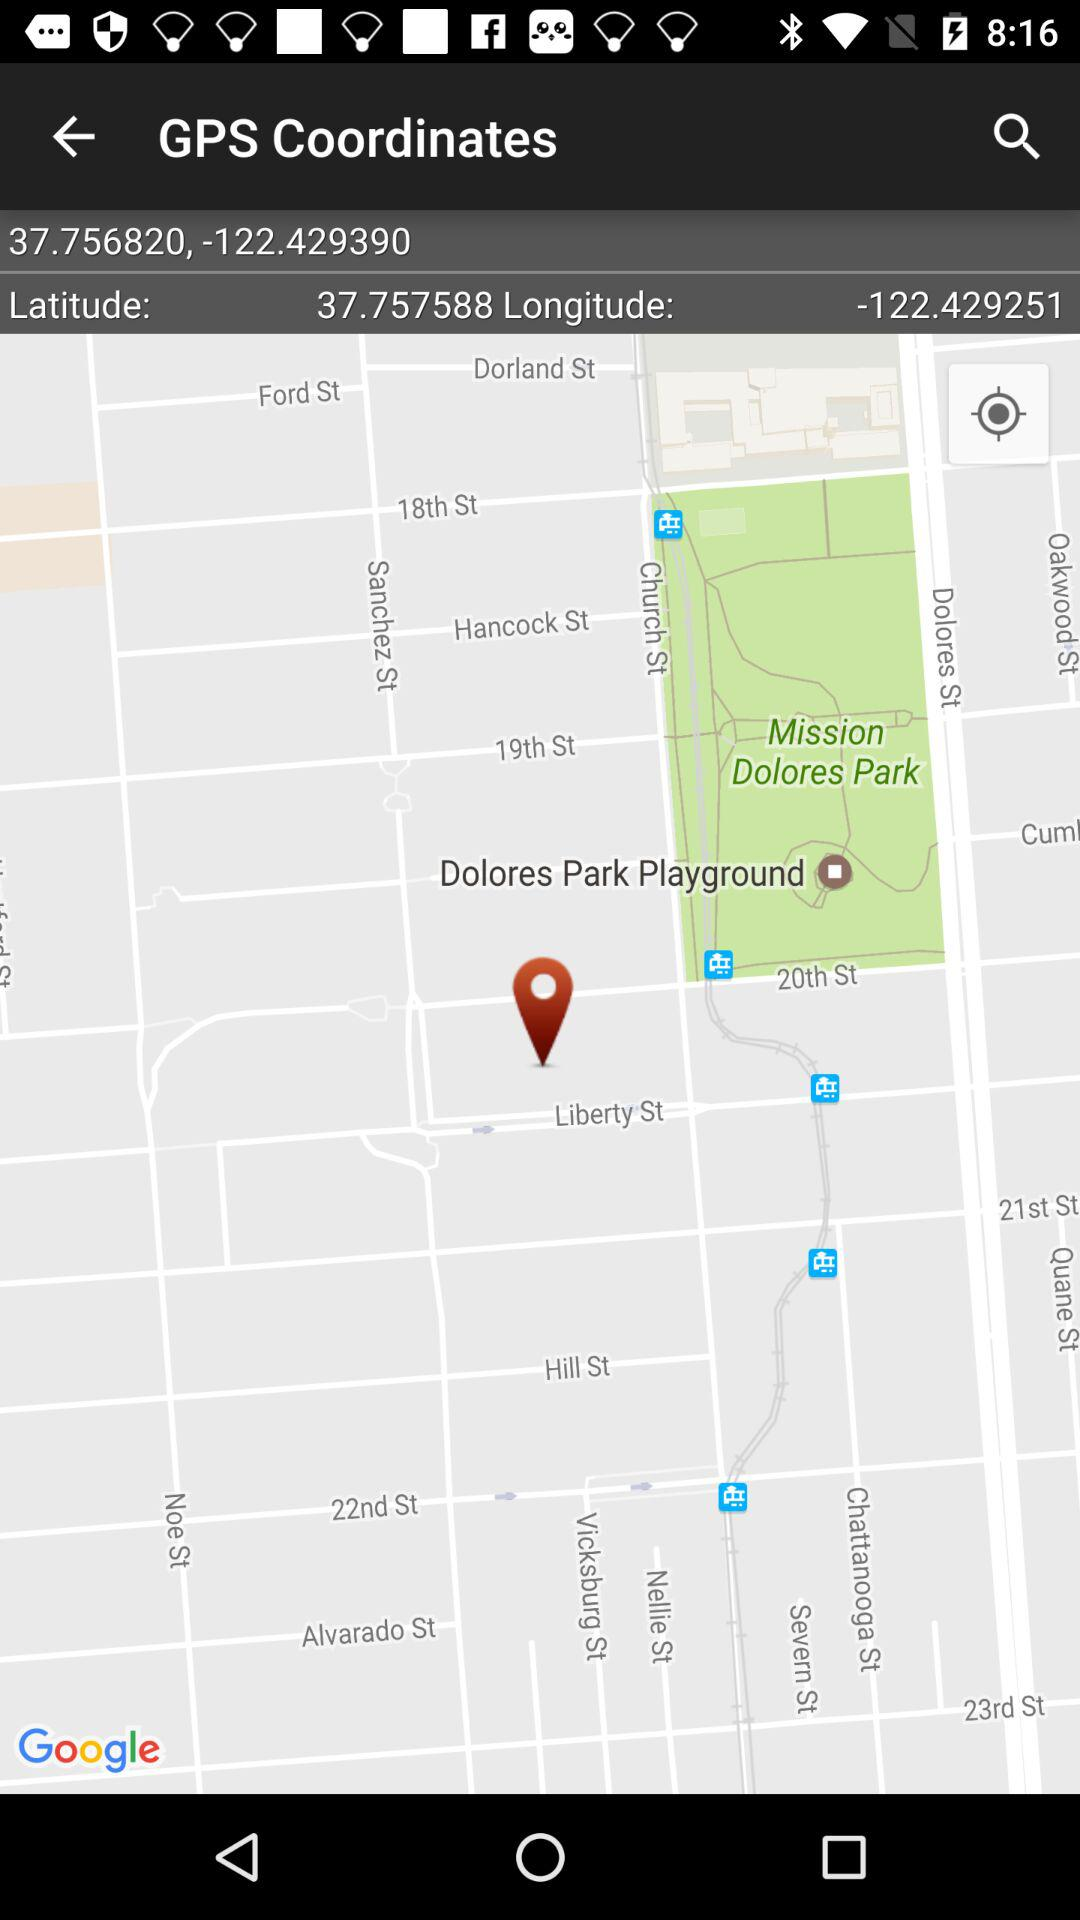What is the longitude value? The longitude is -122.429251. 